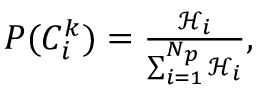Convert formula to latex. <formula><loc_0><loc_0><loc_500><loc_500>\begin{array} { r } { P ( { C _ { i } ^ { k } } ) = \frac { \ m a t h s c r { H } _ { i } } { \sum _ { i = 1 } ^ { N _ { p } } \ m a t h s c r { H } _ { i } } , } \end{array}</formula> 